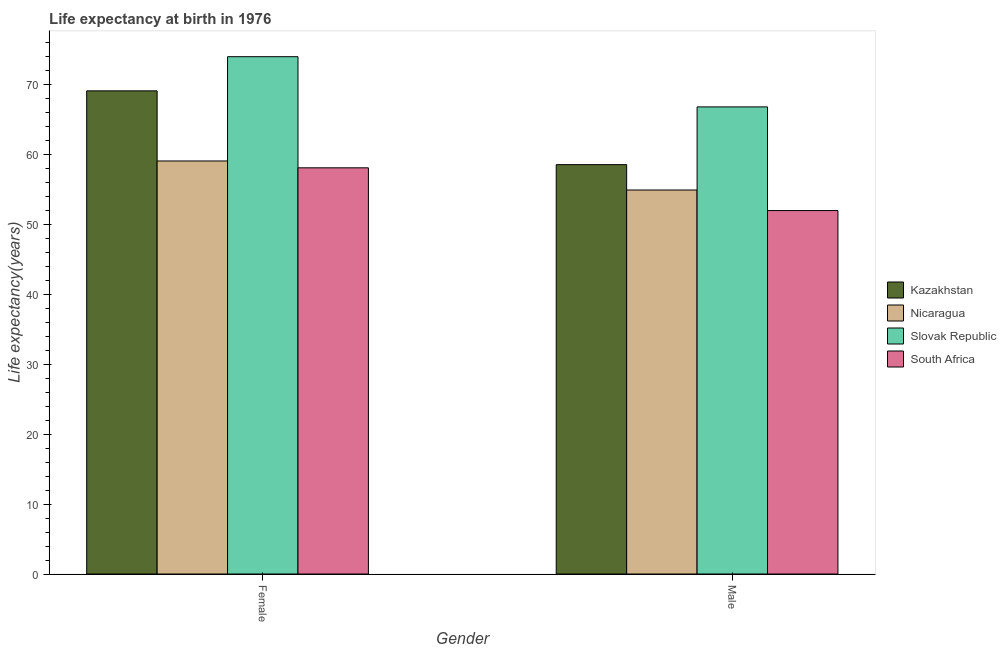How many groups of bars are there?
Your response must be concise. 2. Are the number of bars on each tick of the X-axis equal?
Offer a very short reply. Yes. How many bars are there on the 2nd tick from the left?
Offer a very short reply. 4. How many bars are there on the 1st tick from the right?
Keep it short and to the point. 4. What is the label of the 2nd group of bars from the left?
Offer a terse response. Male. What is the life expectancy(female) in Slovak Republic?
Ensure brevity in your answer.  74. Across all countries, what is the maximum life expectancy(male)?
Your response must be concise. 66.82. Across all countries, what is the minimum life expectancy(female)?
Keep it short and to the point. 58.1. In which country was the life expectancy(female) maximum?
Your answer should be very brief. Slovak Republic. In which country was the life expectancy(male) minimum?
Make the answer very short. South Africa. What is the total life expectancy(female) in the graph?
Keep it short and to the point. 260.31. What is the difference between the life expectancy(male) in Slovak Republic and that in Nicaragua?
Offer a terse response. 11.89. What is the difference between the life expectancy(female) in Kazakhstan and the life expectancy(male) in Nicaragua?
Offer a very short reply. 14.19. What is the average life expectancy(male) per country?
Keep it short and to the point. 58.08. What is the difference between the life expectancy(female) and life expectancy(male) in Slovak Republic?
Provide a short and direct response. 7.18. In how many countries, is the life expectancy(male) greater than 58 years?
Offer a very short reply. 2. What is the ratio of the life expectancy(female) in Kazakhstan to that in Nicaragua?
Provide a succinct answer. 1.17. What does the 1st bar from the left in Female represents?
Your answer should be very brief. Kazakhstan. What does the 4th bar from the right in Male represents?
Ensure brevity in your answer.  Kazakhstan. How many bars are there?
Your answer should be compact. 8. Are all the bars in the graph horizontal?
Give a very brief answer. No. What is the difference between two consecutive major ticks on the Y-axis?
Keep it short and to the point. 10. Are the values on the major ticks of Y-axis written in scientific E-notation?
Ensure brevity in your answer.  No. Does the graph contain any zero values?
Give a very brief answer. No. Does the graph contain grids?
Your response must be concise. No. Where does the legend appear in the graph?
Your answer should be compact. Center right. What is the title of the graph?
Provide a succinct answer. Life expectancy at birth in 1976. Does "Ecuador" appear as one of the legend labels in the graph?
Offer a very short reply. No. What is the label or title of the X-axis?
Give a very brief answer. Gender. What is the label or title of the Y-axis?
Ensure brevity in your answer.  Life expectancy(years). What is the Life expectancy(years) in Kazakhstan in Female?
Your answer should be compact. 69.12. What is the Life expectancy(years) of Nicaragua in Female?
Make the answer very short. 59.09. What is the Life expectancy(years) in Slovak Republic in Female?
Offer a very short reply. 74. What is the Life expectancy(years) in South Africa in Female?
Your response must be concise. 58.1. What is the Life expectancy(years) of Kazakhstan in Male?
Offer a terse response. 58.56. What is the Life expectancy(years) of Nicaragua in Male?
Ensure brevity in your answer.  54.93. What is the Life expectancy(years) of Slovak Republic in Male?
Provide a short and direct response. 66.82. What is the Life expectancy(years) in South Africa in Male?
Your answer should be very brief. 51.99. Across all Gender, what is the maximum Life expectancy(years) of Kazakhstan?
Make the answer very short. 69.12. Across all Gender, what is the maximum Life expectancy(years) in Nicaragua?
Provide a short and direct response. 59.09. Across all Gender, what is the maximum Life expectancy(years) in Slovak Republic?
Give a very brief answer. 74. Across all Gender, what is the maximum Life expectancy(years) in South Africa?
Offer a terse response. 58.1. Across all Gender, what is the minimum Life expectancy(years) in Kazakhstan?
Offer a terse response. 58.56. Across all Gender, what is the minimum Life expectancy(years) in Nicaragua?
Give a very brief answer. 54.93. Across all Gender, what is the minimum Life expectancy(years) in Slovak Republic?
Offer a terse response. 66.82. Across all Gender, what is the minimum Life expectancy(years) of South Africa?
Your answer should be very brief. 51.99. What is the total Life expectancy(years) of Kazakhstan in the graph?
Offer a terse response. 127.68. What is the total Life expectancy(years) in Nicaragua in the graph?
Give a very brief answer. 114.02. What is the total Life expectancy(years) of Slovak Republic in the graph?
Give a very brief answer. 140.82. What is the total Life expectancy(years) in South Africa in the graph?
Make the answer very short. 110.1. What is the difference between the Life expectancy(years) of Kazakhstan in Female and that in Male?
Make the answer very short. 10.56. What is the difference between the Life expectancy(years) in Nicaragua in Female and that in Male?
Offer a very short reply. 4.15. What is the difference between the Life expectancy(years) in Slovak Republic in Female and that in Male?
Ensure brevity in your answer.  7.18. What is the difference between the Life expectancy(years) of South Africa in Female and that in Male?
Offer a terse response. 6.11. What is the difference between the Life expectancy(years) of Kazakhstan in Female and the Life expectancy(years) of Nicaragua in Male?
Your answer should be very brief. 14.19. What is the difference between the Life expectancy(years) in Kazakhstan in Female and the Life expectancy(years) in Slovak Republic in Male?
Your answer should be very brief. 2.3. What is the difference between the Life expectancy(years) of Kazakhstan in Female and the Life expectancy(years) of South Africa in Male?
Your answer should be compact. 17.12. What is the difference between the Life expectancy(years) in Nicaragua in Female and the Life expectancy(years) in Slovak Republic in Male?
Ensure brevity in your answer.  -7.74. What is the difference between the Life expectancy(years) in Nicaragua in Female and the Life expectancy(years) in South Africa in Male?
Provide a short and direct response. 7.09. What is the difference between the Life expectancy(years) in Slovak Republic in Female and the Life expectancy(years) in South Africa in Male?
Offer a very short reply. 22.01. What is the average Life expectancy(years) in Kazakhstan per Gender?
Your answer should be compact. 63.84. What is the average Life expectancy(years) of Nicaragua per Gender?
Ensure brevity in your answer.  57.01. What is the average Life expectancy(years) in Slovak Republic per Gender?
Give a very brief answer. 70.41. What is the average Life expectancy(years) in South Africa per Gender?
Make the answer very short. 55.05. What is the difference between the Life expectancy(years) of Kazakhstan and Life expectancy(years) of Nicaragua in Female?
Provide a succinct answer. 10.03. What is the difference between the Life expectancy(years) of Kazakhstan and Life expectancy(years) of Slovak Republic in Female?
Offer a very short reply. -4.89. What is the difference between the Life expectancy(years) of Kazakhstan and Life expectancy(years) of South Africa in Female?
Your response must be concise. 11.01. What is the difference between the Life expectancy(years) of Nicaragua and Life expectancy(years) of Slovak Republic in Female?
Provide a short and direct response. -14.92. What is the difference between the Life expectancy(years) in Slovak Republic and Life expectancy(years) in South Africa in Female?
Provide a short and direct response. 15.9. What is the difference between the Life expectancy(years) in Kazakhstan and Life expectancy(years) in Nicaragua in Male?
Offer a very short reply. 3.63. What is the difference between the Life expectancy(years) in Kazakhstan and Life expectancy(years) in Slovak Republic in Male?
Make the answer very short. -8.26. What is the difference between the Life expectancy(years) in Kazakhstan and Life expectancy(years) in South Africa in Male?
Your answer should be compact. 6.57. What is the difference between the Life expectancy(years) of Nicaragua and Life expectancy(years) of Slovak Republic in Male?
Give a very brief answer. -11.89. What is the difference between the Life expectancy(years) in Nicaragua and Life expectancy(years) in South Africa in Male?
Keep it short and to the point. 2.94. What is the difference between the Life expectancy(years) in Slovak Republic and Life expectancy(years) in South Africa in Male?
Offer a terse response. 14.83. What is the ratio of the Life expectancy(years) of Kazakhstan in Female to that in Male?
Your answer should be very brief. 1.18. What is the ratio of the Life expectancy(years) of Nicaragua in Female to that in Male?
Make the answer very short. 1.08. What is the ratio of the Life expectancy(years) in Slovak Republic in Female to that in Male?
Your answer should be compact. 1.11. What is the ratio of the Life expectancy(years) of South Africa in Female to that in Male?
Your answer should be very brief. 1.12. What is the difference between the highest and the second highest Life expectancy(years) of Kazakhstan?
Your response must be concise. 10.56. What is the difference between the highest and the second highest Life expectancy(years) of Nicaragua?
Offer a very short reply. 4.15. What is the difference between the highest and the second highest Life expectancy(years) in Slovak Republic?
Your answer should be compact. 7.18. What is the difference between the highest and the second highest Life expectancy(years) in South Africa?
Ensure brevity in your answer.  6.11. What is the difference between the highest and the lowest Life expectancy(years) in Kazakhstan?
Provide a short and direct response. 10.56. What is the difference between the highest and the lowest Life expectancy(years) in Nicaragua?
Give a very brief answer. 4.15. What is the difference between the highest and the lowest Life expectancy(years) in Slovak Republic?
Provide a succinct answer. 7.18. What is the difference between the highest and the lowest Life expectancy(years) in South Africa?
Keep it short and to the point. 6.11. 